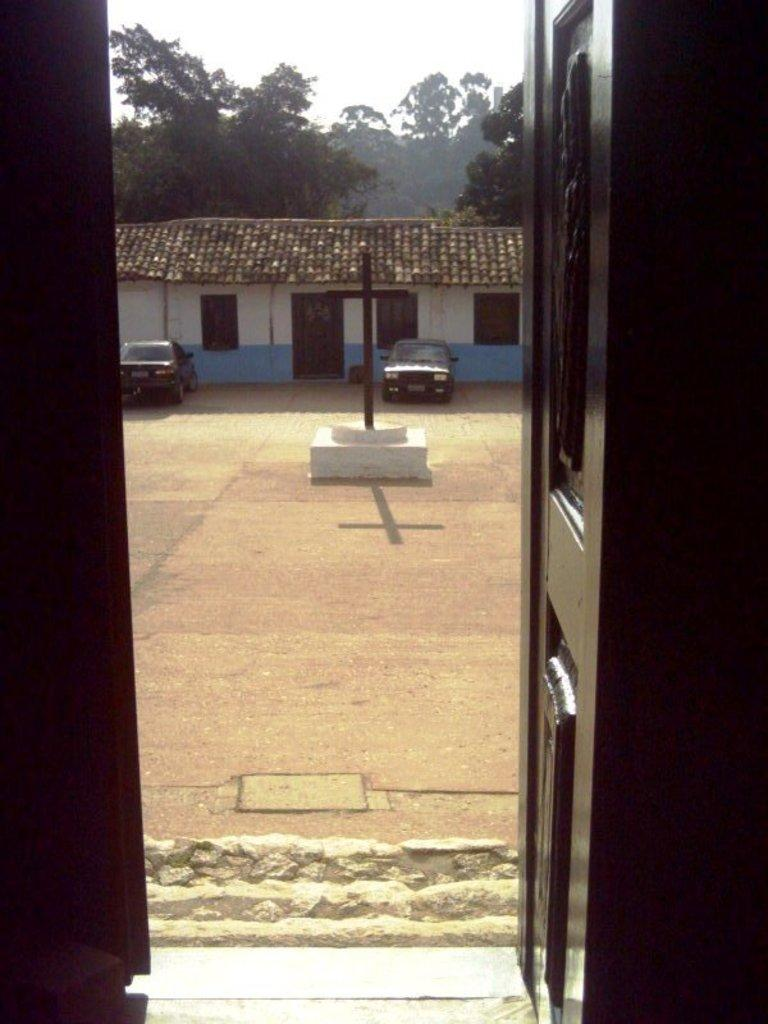What is one of the main structures visible in the image? There is a house in the image. What is located near the house? There is a door in the image. What type of vehicles can be seen in the image? There are cars in the image. What is the memorial on the ground in the image? There is a cross memorial on the ground in the image. What can be seen in the background of the image? There are trees in the background of the image. What is visible above the trees and the house? The sky is visible in the image. How does the girl express her feelings of hate in the image? There is no girl present in the image, and therefore no expression of hate can be observed. What is the level of quietness in the image? The image does not convey any information about the level of quietness, as it is a still image. 